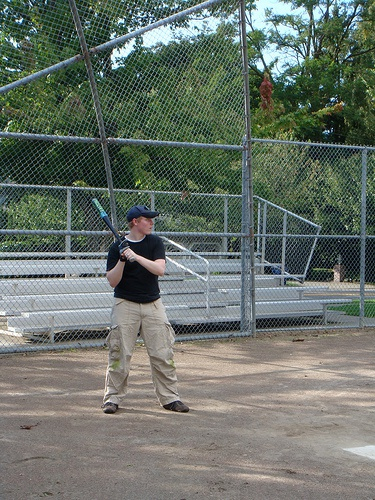Describe the objects in this image and their specific colors. I can see bench in darkgreen, darkgray, gray, and lightgray tones, people in darkgreen, darkgray, black, and gray tones, bench in darkgreen, darkgray, and lightgray tones, and baseball bat in darkgreen, blue, gray, black, and teal tones in this image. 